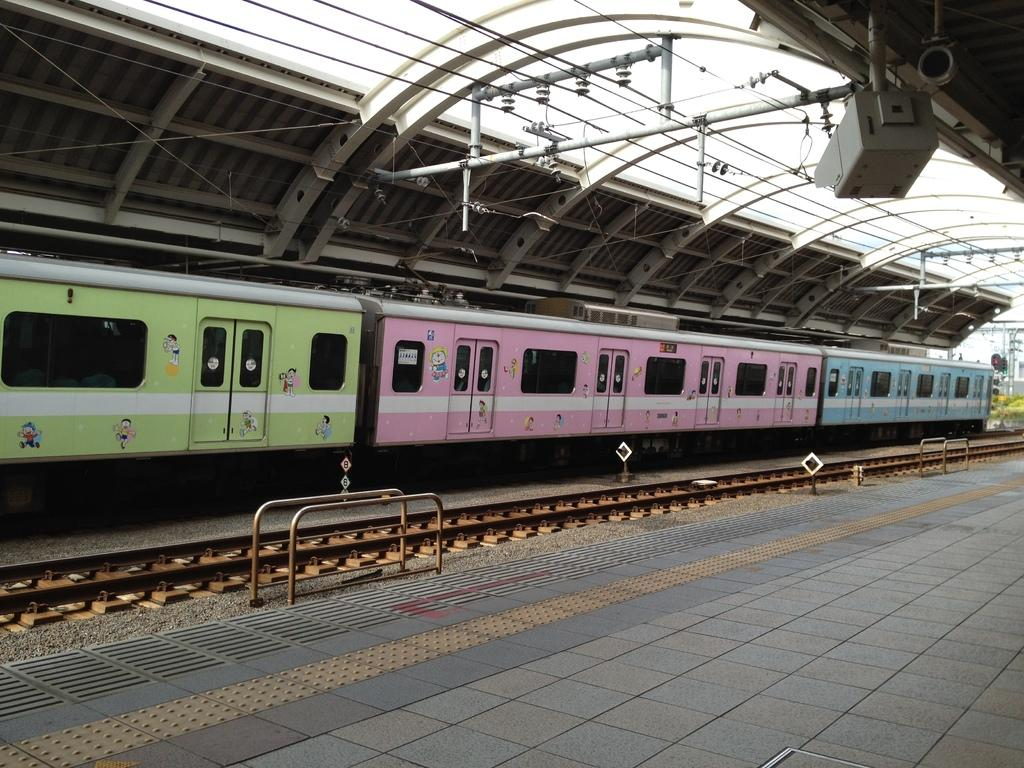What is the main subject of the image? The main subject of the image is a train. Where is the train located in the image? The train is on a train track. What can be seen around the train in the image? There are poles around the train. What other objects are visible in the image? There are grills and wires attached to the roof in the image. How many ears of corn can be seen on the cushions in the image? There are no ears of corn or cushions present in the image. What type of boys are playing near the train in the image? There are no boys present in the image; it only features a train, train track, poles, grills, and wires. 